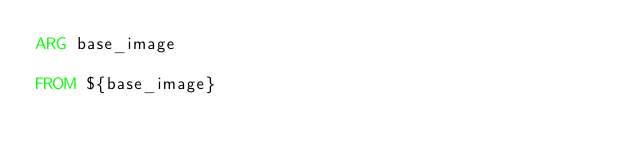<code> <loc_0><loc_0><loc_500><loc_500><_Dockerfile_>ARG base_image

FROM ${base_image}
</code> 